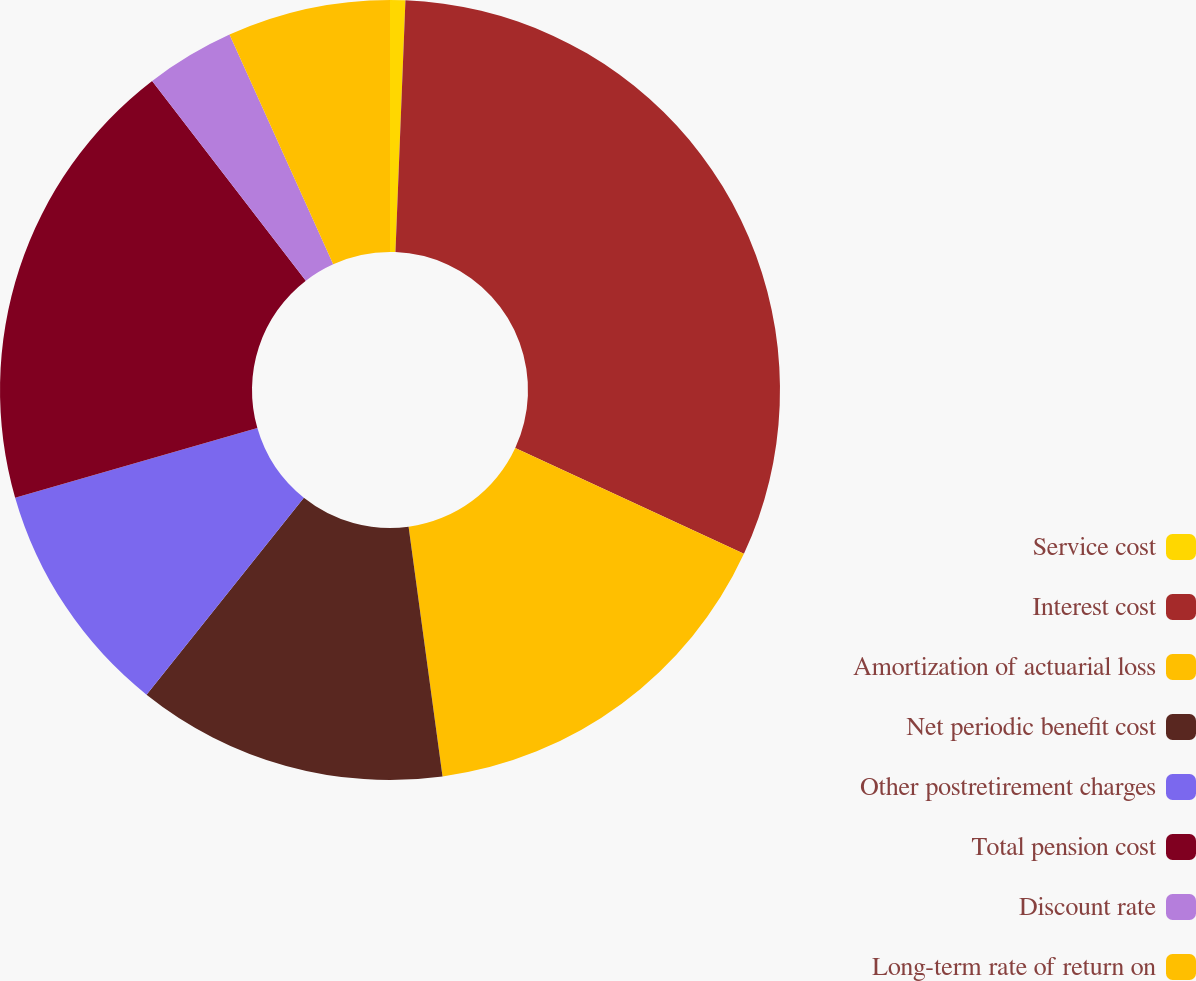Convert chart to OTSL. <chart><loc_0><loc_0><loc_500><loc_500><pie_chart><fcel>Service cost<fcel>Interest cost<fcel>Amortization of actuarial loss<fcel>Net periodic benefit cost<fcel>Other postretirement charges<fcel>Total pension cost<fcel>Discount rate<fcel>Long-term rate of return on<nl><fcel>0.63%<fcel>31.27%<fcel>15.95%<fcel>12.88%<fcel>9.82%<fcel>19.01%<fcel>3.69%<fcel>6.75%<nl></chart> 